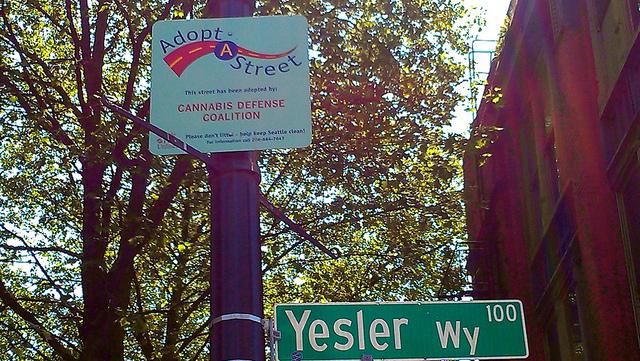Who takes care of this street's upkeep?
Answer briefly. Cannabis defense coalition. What color is the pole?
Keep it brief. Black. What is the name of the street?
Be succinct. Yesler wy. 